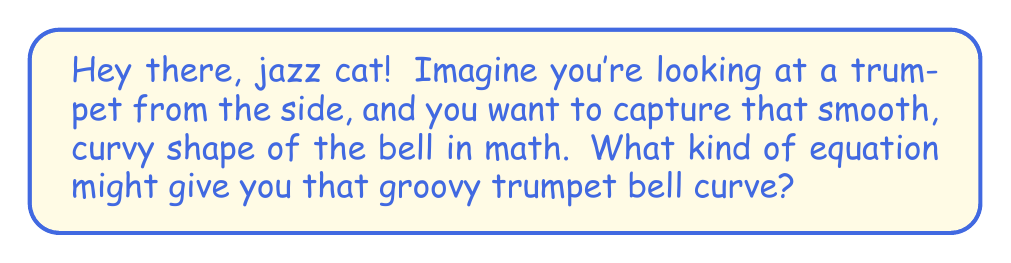Show me your answer to this math problem. Alright, let's break this down in a cool, jazzy way:

1. The trumpet bell has a shape that starts narrow and then suddenly flares out. This is similar to what mathematicians call an "exponential curve."

2. But it's not just any exponential curve. It's more like an exponential curve that's been flipped and rotated. In math speak, we call this a "rotated exponential function."

3. The basic exponential function looks like this: $y = e^x$. But we need to flip it and rotate it to get our trumpet shape.

4. To flip it, we can use $-e^x$ instead of $e^x$.

5. To rotate it, we can swap $x$ and $y$. This gives us $x = -e^y$.

6. Now, to make it look more like a trumpet bell, we might want to stretch or shrink it a bit. We can do this by adding some numbers:

   $x = a(-e^y) + b$

   Where $a$ controls how wide the bell is, and $b$ moves the whole shape left or right.

7. Finally, to make it the right way up (opening to the right), we can flip the $x$ and $y$ again:

   $y = a(-e^x) + b$

This equation will give us a smooth curve that opens up like a trumpet bell!

[asy]
import graph;
size(200,200);
real f(real x) {return -exp(x)+5;}
draw(graph(f,-2,1.5));
label("Bell opening",(1.5,f(1.5)),E);
label("Mouthpiece end",(-2,f(-2)),W);
[/asy]
Answer: $y = a(-e^x) + b$, where $a$ and $b$ are constants 